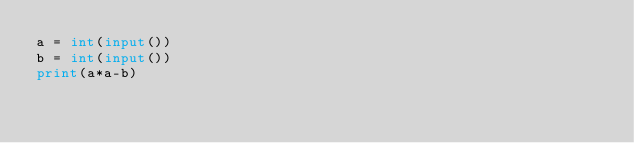<code> <loc_0><loc_0><loc_500><loc_500><_Python_>a = int(input())
b = int(input())
print(a*a-b)</code> 